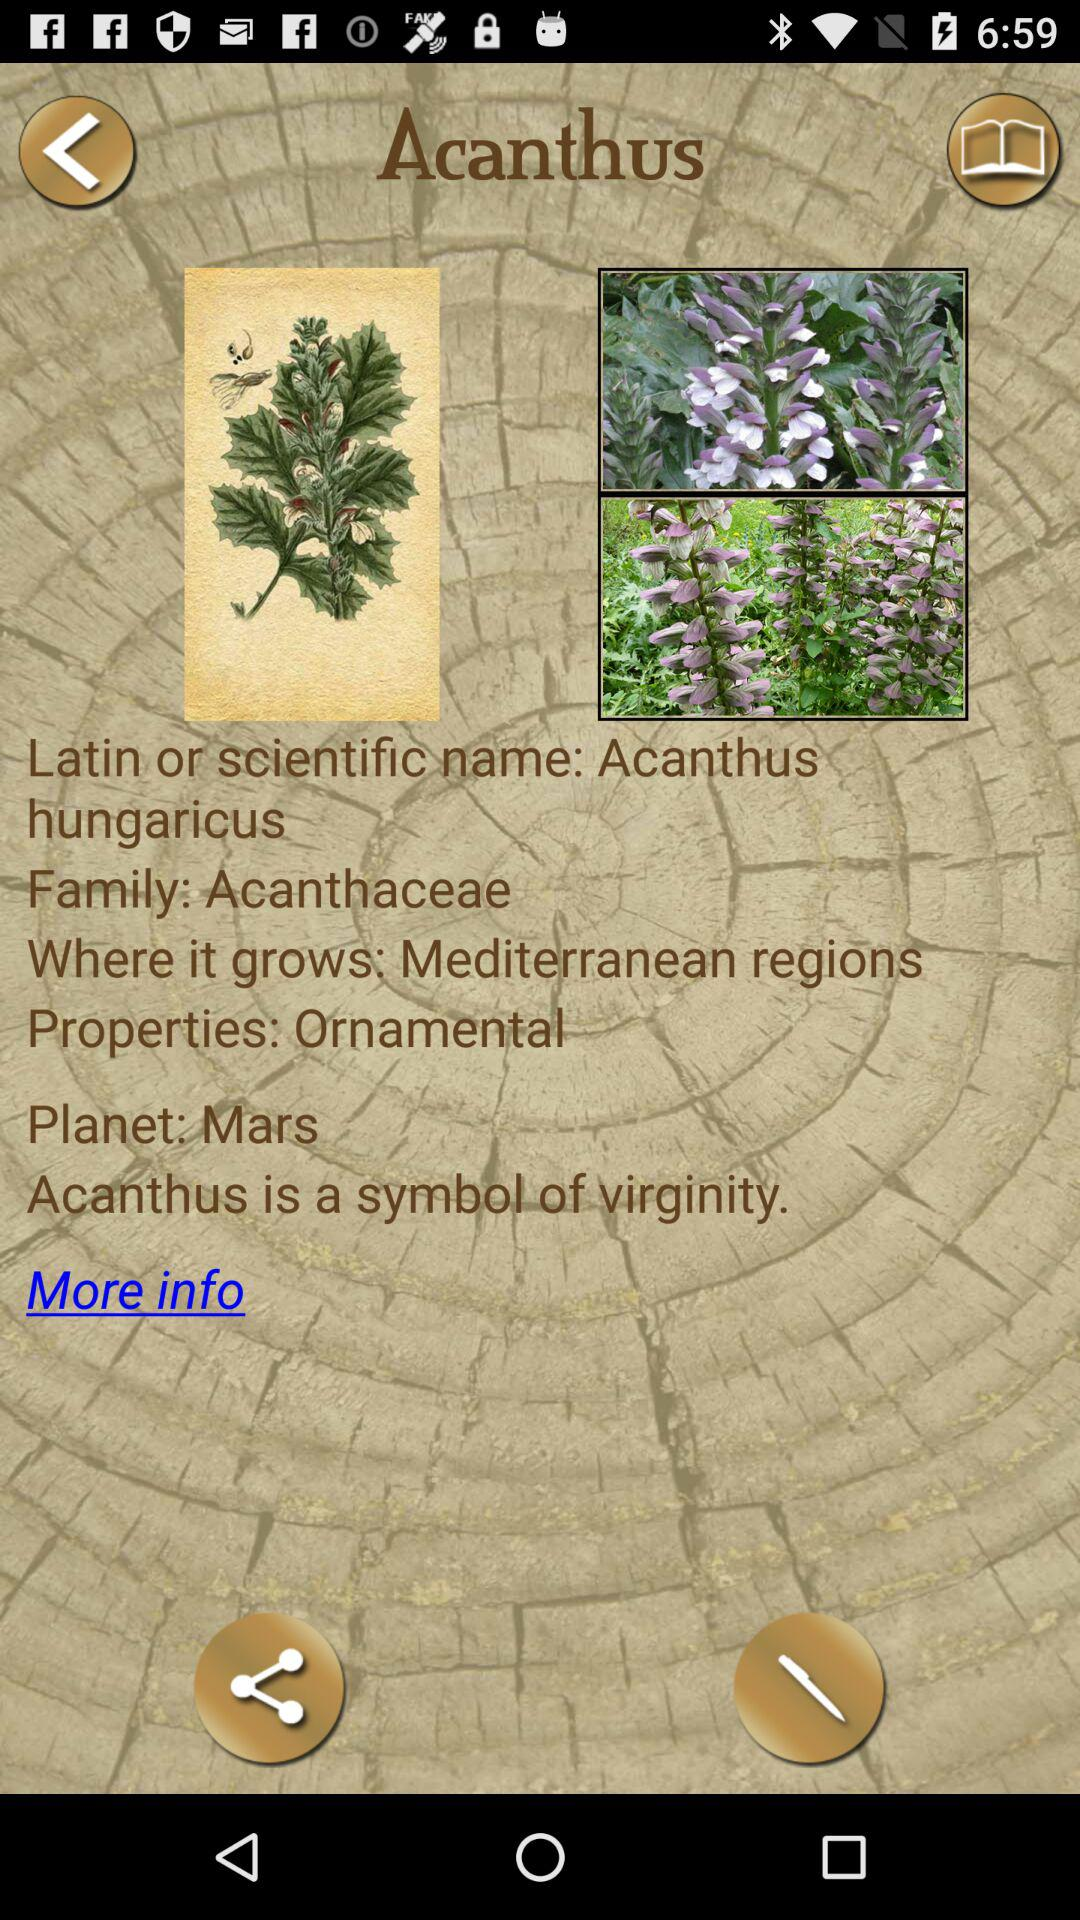Where does Acanthus grow? It grows in "Mediterranean regions". 